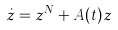Convert formula to latex. <formula><loc_0><loc_0><loc_500><loc_500>\dot { z } = z ^ { N } + A ( t ) z</formula> 